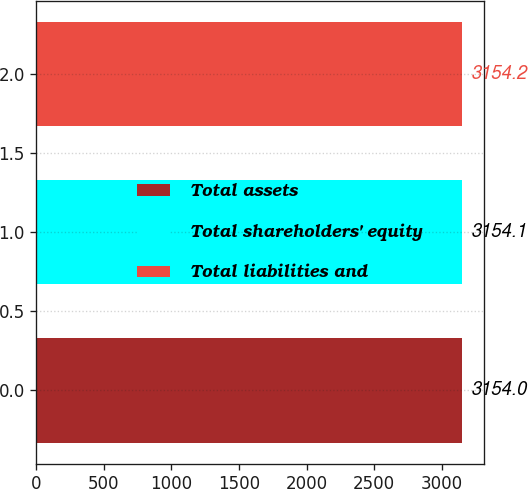Convert chart to OTSL. <chart><loc_0><loc_0><loc_500><loc_500><bar_chart><fcel>Total assets<fcel>Total shareholders' equity<fcel>Total liabilities and<nl><fcel>3154<fcel>3154.1<fcel>3154.2<nl></chart> 